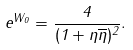Convert formula to latex. <formula><loc_0><loc_0><loc_500><loc_500>e ^ { W _ { 0 } } = { \frac { 4 } { ( 1 + \eta \overline { \eta } ) ^ { 2 } } } .</formula> 